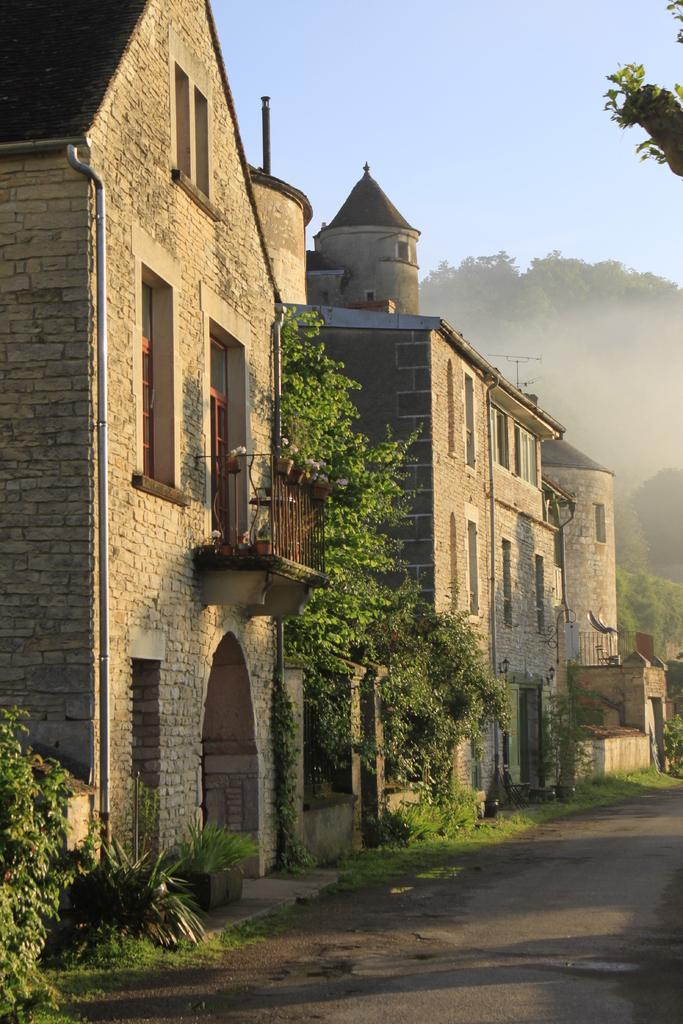What is located in the center of the image? There are buildings, trees, and plants in the center of the image. What can be seen at the bottom of the image? There is a walkway at the bottom of the image. What is visible in the background of the image? There are trees in the background of the image. What is visible at the top of the image? The sky is visible at the top of the image. How does the pollution affect the trees in the image? There is no mention of pollution in the image, so we cannot determine its effect on the trees. What type of yoke is being used by the person in the image? There is no person or yoke present in the image. 